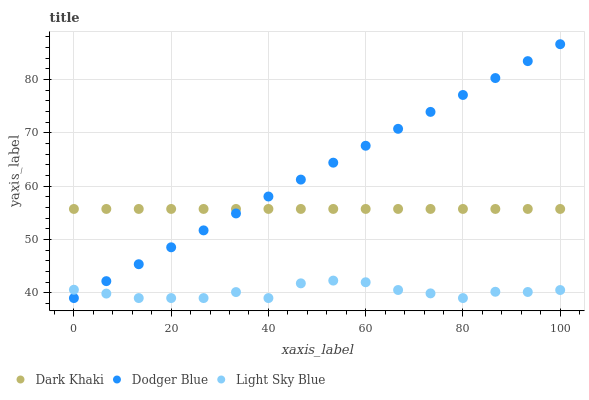Does Light Sky Blue have the minimum area under the curve?
Answer yes or no. Yes. Does Dodger Blue have the maximum area under the curve?
Answer yes or no. Yes. Does Dodger Blue have the minimum area under the curve?
Answer yes or no. No. Does Light Sky Blue have the maximum area under the curve?
Answer yes or no. No. Is Dodger Blue the smoothest?
Answer yes or no. Yes. Is Light Sky Blue the roughest?
Answer yes or no. Yes. Is Light Sky Blue the smoothest?
Answer yes or no. No. Is Dodger Blue the roughest?
Answer yes or no. No. Does Light Sky Blue have the lowest value?
Answer yes or no. Yes. Does Dodger Blue have the highest value?
Answer yes or no. Yes. Does Light Sky Blue have the highest value?
Answer yes or no. No. Is Light Sky Blue less than Dark Khaki?
Answer yes or no. Yes. Is Dark Khaki greater than Light Sky Blue?
Answer yes or no. Yes. Does Dark Khaki intersect Dodger Blue?
Answer yes or no. Yes. Is Dark Khaki less than Dodger Blue?
Answer yes or no. No. Is Dark Khaki greater than Dodger Blue?
Answer yes or no. No. Does Light Sky Blue intersect Dark Khaki?
Answer yes or no. No. 